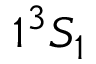<formula> <loc_0><loc_0><loc_500><loc_500>1 ^ { 3 } S _ { 1 }</formula> 